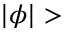<formula> <loc_0><loc_0><loc_500><loc_500>| \phi | ></formula> 